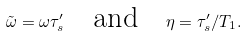Convert formula to latex. <formula><loc_0><loc_0><loc_500><loc_500>\tilde { \omega } = \omega \tau ^ { \prime } _ { s } \quad \text {and} \quad \eta = \tau ^ { \prime } _ { s } / T _ { 1 } .</formula> 